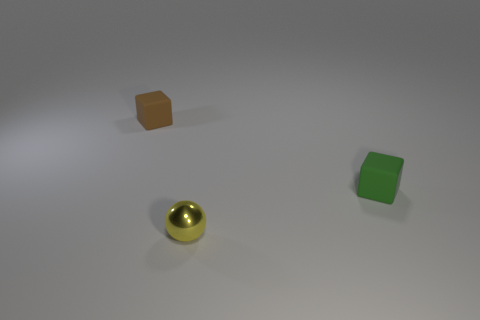Add 2 brown matte blocks. How many objects exist? 5 Subtract all spheres. How many objects are left? 2 Subtract 0 brown spheres. How many objects are left? 3 Subtract all brown rubber cubes. Subtract all tiny green things. How many objects are left? 1 Add 1 green things. How many green things are left? 2 Add 1 tiny brown matte cubes. How many tiny brown matte cubes exist? 2 